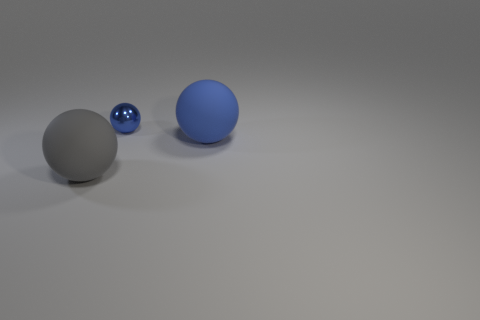How many other large things have the same color as the metallic thing?
Provide a succinct answer. 1. There is a shiny ball; does it have the same color as the matte object that is to the right of the gray sphere?
Ensure brevity in your answer.  Yes. Is there another thing of the same color as the small shiny thing?
Your answer should be very brief. Yes. What is the size of the blue shiny thing that is the same shape as the gray object?
Make the answer very short. Small. What is the shape of the big matte thing that is the same color as the shiny object?
Ensure brevity in your answer.  Sphere. There is a blue thing that is on the left side of the big blue matte object; what size is it?
Offer a terse response. Small. Is the number of gray balls that are on the right side of the gray object the same as the number of things?
Your answer should be very brief. No. Is there any other thing that has the same material as the large gray sphere?
Your answer should be compact. Yes. Does the big thing that is on the left side of the small metal ball have the same material as the large blue thing?
Offer a terse response. Yes. Are there fewer big things that are behind the tiny blue shiny sphere than blue metallic spheres?
Your answer should be compact. Yes. 